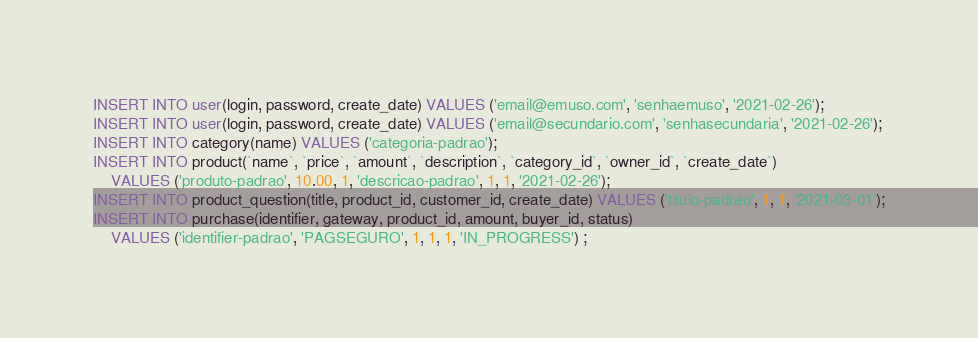<code> <loc_0><loc_0><loc_500><loc_500><_SQL_>INSERT INTO user(login, password, create_date) VALUES ('email@emuso.com', 'senhaemuso', '2021-02-26');
INSERT INTO user(login, password, create_date) VALUES ('email@secundario.com', 'senhasecundaria', '2021-02-26');
INSERT INTO category(name) VALUES ('categoria-padrao');
INSERT INTO product(`name`, `price`, `amount`, `description`, `category_id`, `owner_id`, `create_date`)
    VALUES ('produto-padrao', 10.00, 1, 'descricao-padrao', 1, 1, '2021-02-26');
INSERT INTO product_question(title, product_id, customer_id, create_date) VALUES ('titulo-padrao', 1, 1, '2021-03-01');
INSERT INTO purchase(identifier, gateway, product_id, amount, buyer_id, status)
    VALUES ('identifier-padrao', 'PAGSEGURO', 1, 1, 1, 'IN_PROGRESS') ;</code> 